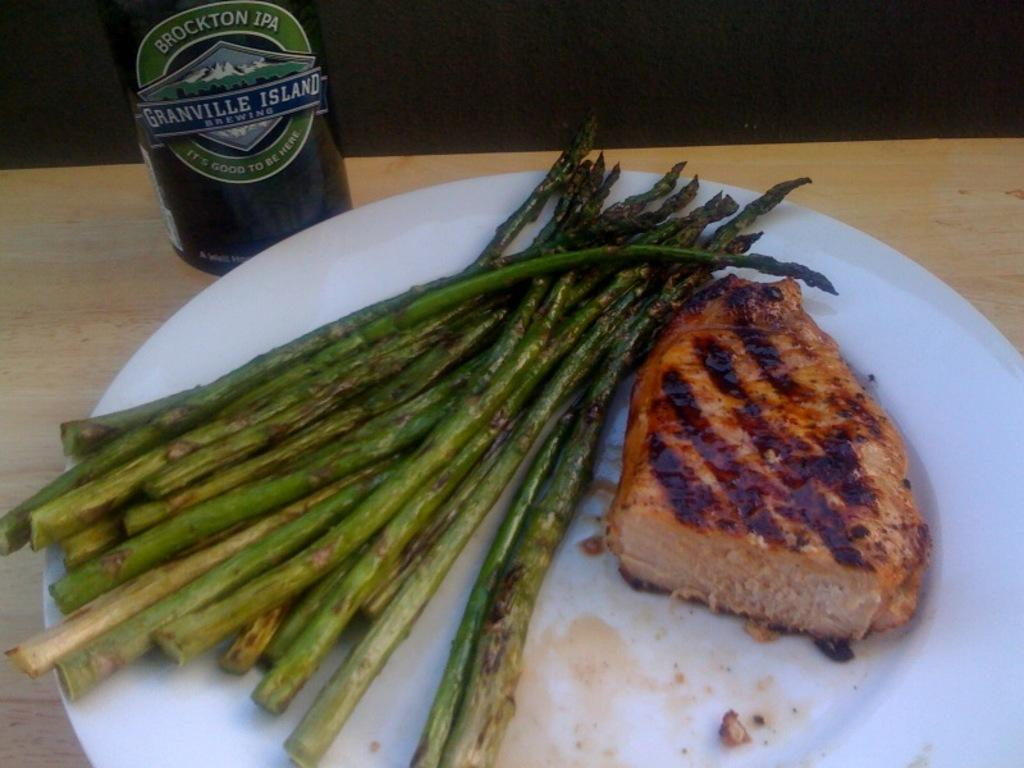What is on the table in the image? There is a plate on the table in the image. What is on the plate? The plate contains food and sticks. Can you describe the bottle in the image? There is a bottle in the top left of the image. What type of horn can be seen in the image? There is no horn present in the image. How much salt is on the plate in the image? There is no salt mentioned or visible on the plate in the image. 